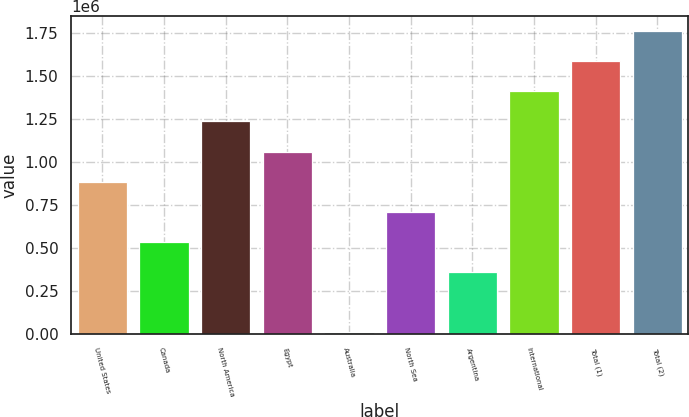<chart> <loc_0><loc_0><loc_500><loc_500><bar_chart><fcel>United States<fcel>Canada<fcel>North America<fcel>Egypt<fcel>Australia<fcel>North Sea<fcel>Argentina<fcel>International<fcel>Total (1)<fcel>Total (2)<nl><fcel>884296<fcel>534490<fcel>1.2341e+06<fcel>1.0592e+06<fcel>9779<fcel>709393<fcel>359586<fcel>1.40901e+06<fcel>1.58391e+06<fcel>1.75881e+06<nl></chart> 